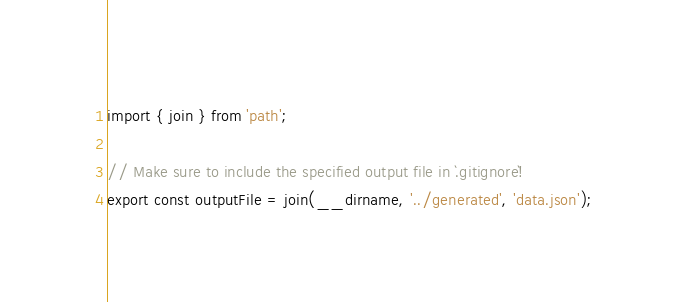Convert code to text. <code><loc_0><loc_0><loc_500><loc_500><_TypeScript_>import { join } from 'path';

// Make sure to include the specified output file in `.gitignore`!
export const outputFile = join(__dirname, '../generated', 'data.json');
</code> 